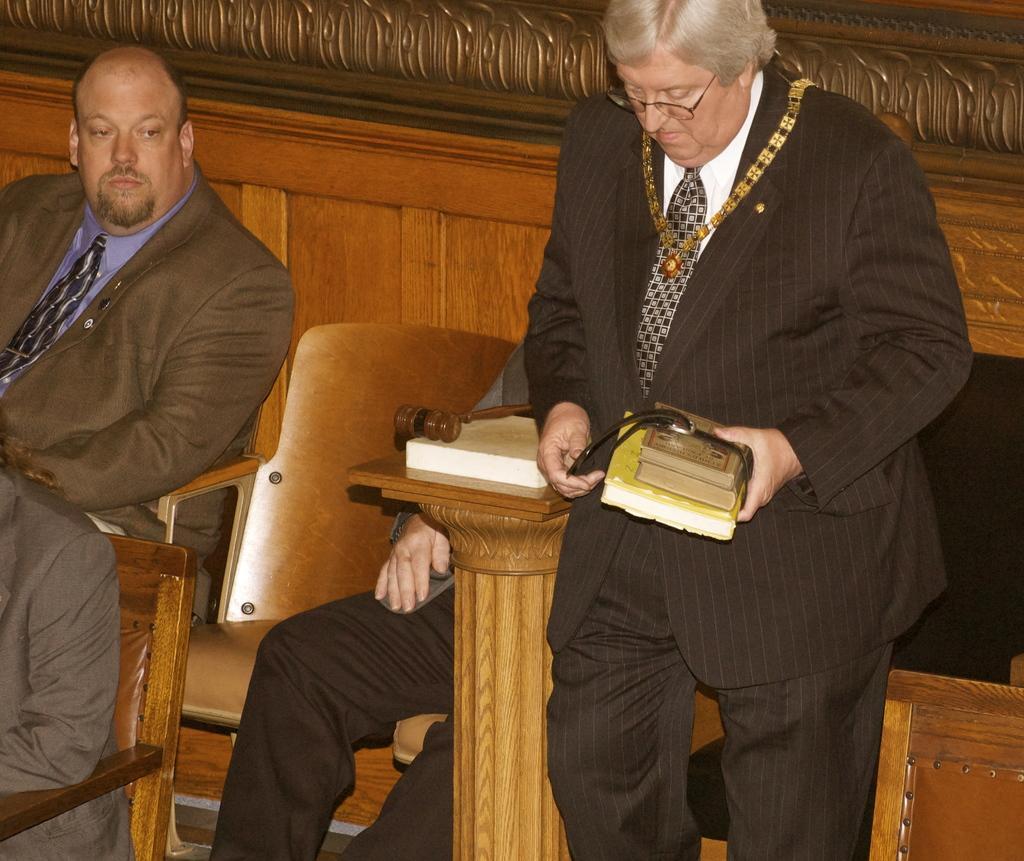In one or two sentences, can you explain what this image depicts? In this image a person holding few books in his hand. He is wearing suit, tie, chain and spectacles. There is a table having a book and a hammer on it. Behind it there is a person sitting on the chair. There is a person wearing a suit and tie is sitting on the chair, before him there is a person wearing a suit is sitting on the chair. Behind them there is a wooden wall. 